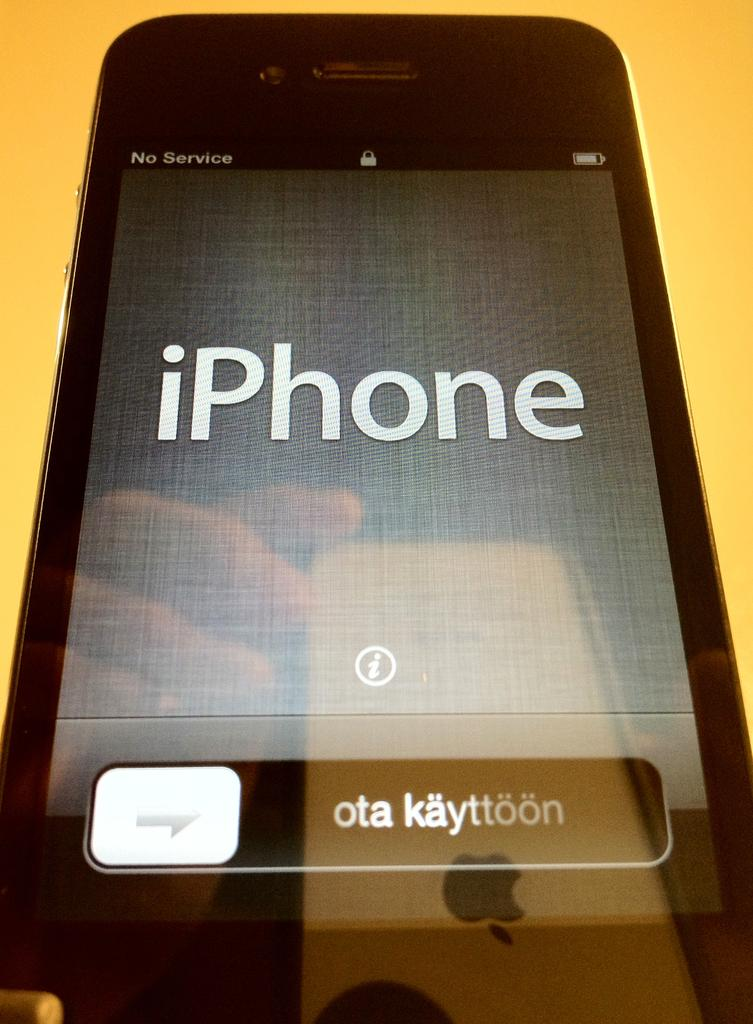<image>
Offer a succinct explanation of the picture presented. Screen of a black phone that says "iPhone" in it. 